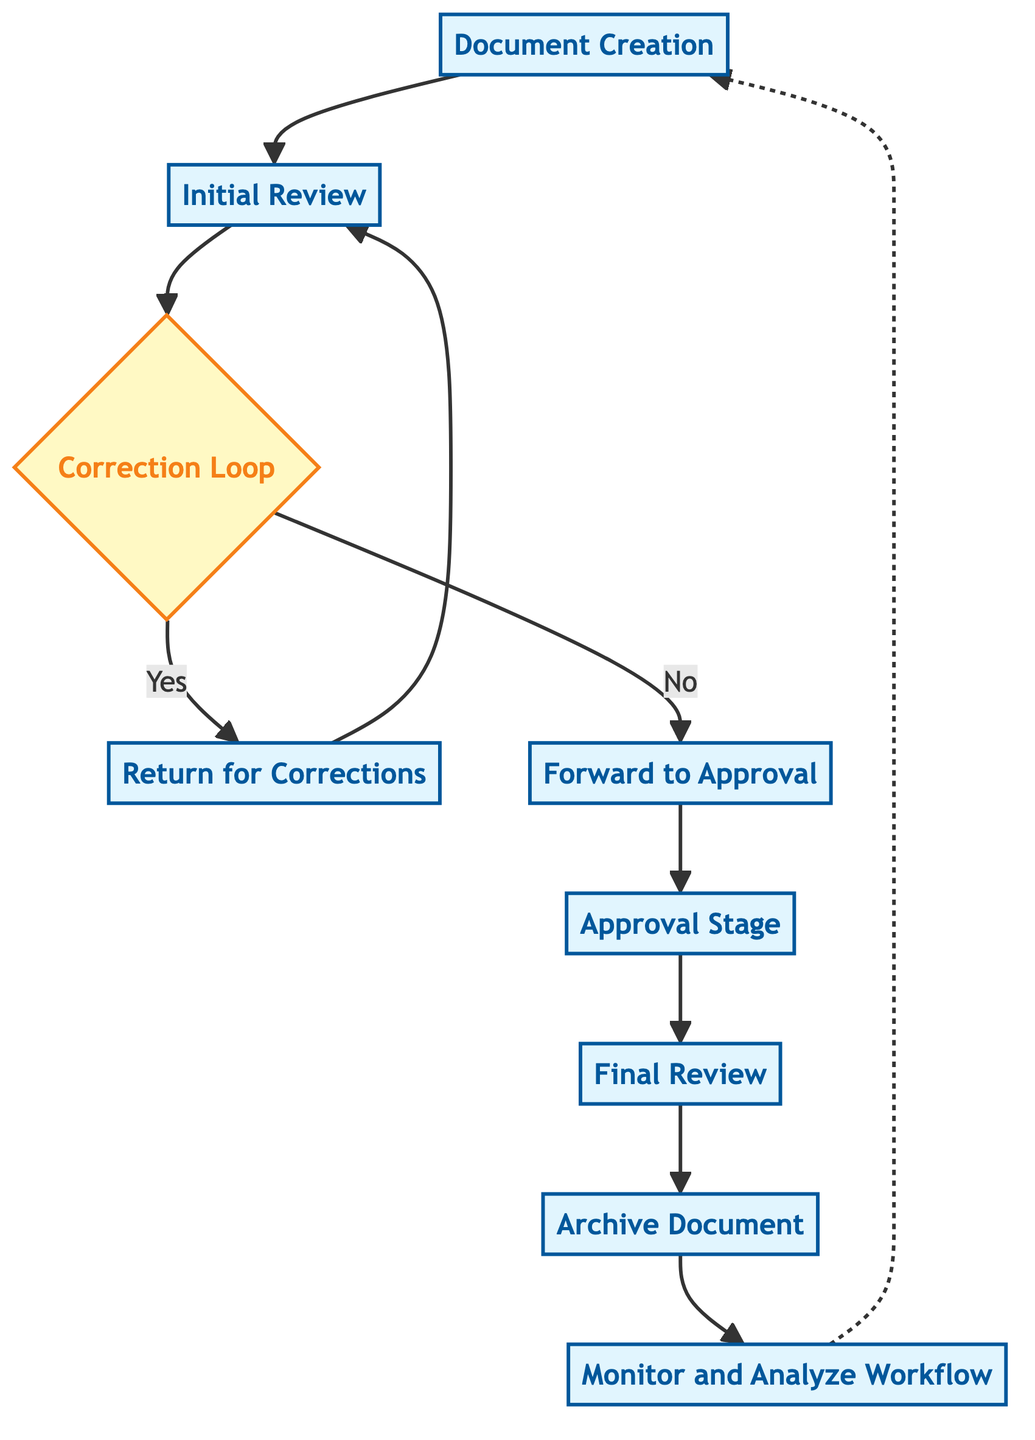What is the first process step in the workflow? The diagram starts with "Document Creation," which is the first process indicated.
Answer: Document Creation How many process steps are there in total? Counting all the process nodes in the diagram (Document Creation, Initial Review, Return for Corrections, Forward to Approval, Approval Stage, Final Review, Archive Document, Monitor and Analyze Workflow), there are eight process steps.
Answer: 8 What is the decision point in the workflow? The decision point is labeled "Correction Loop," where the flow directs to either corrections or approval based on the condition.
Answer: Correction Loop What action follows after "Forward to Approval"? The subsequent action after "Forward to Approval" is "Approval Stage," indicating the flow after approval submission.
Answer: Approval Stage What step is taken if the document needs corrections? If the document needs corrections, the workflow directs back to "Return for Corrections" for necessary adjustments.
Answer: Return for Corrections Which process comes after the "Approval Stage"? Following the "Approval Stage," the next step is "Final Review," as stipulated in the flow.
Answer: Final Review How does the workflow monitor for improvements? The workflow monitors for improvements through a process called "Monitor and Analyze Workflow," where ongoing analysis is performed.
Answer: Monitor and Analyze Workflow What is the process that occurs after the "Final Review"? After the "Final Review," the workflow continues to "Archive Document," where the completed document is stored for future reference.
Answer: Archive Document What is the last action in the workflow before it loops? The last action before looping back to "Document Creation" is "Monitor and Analyze Workflow," highlighting continuous monitoring.
Answer: Monitor and Analyze Workflow 